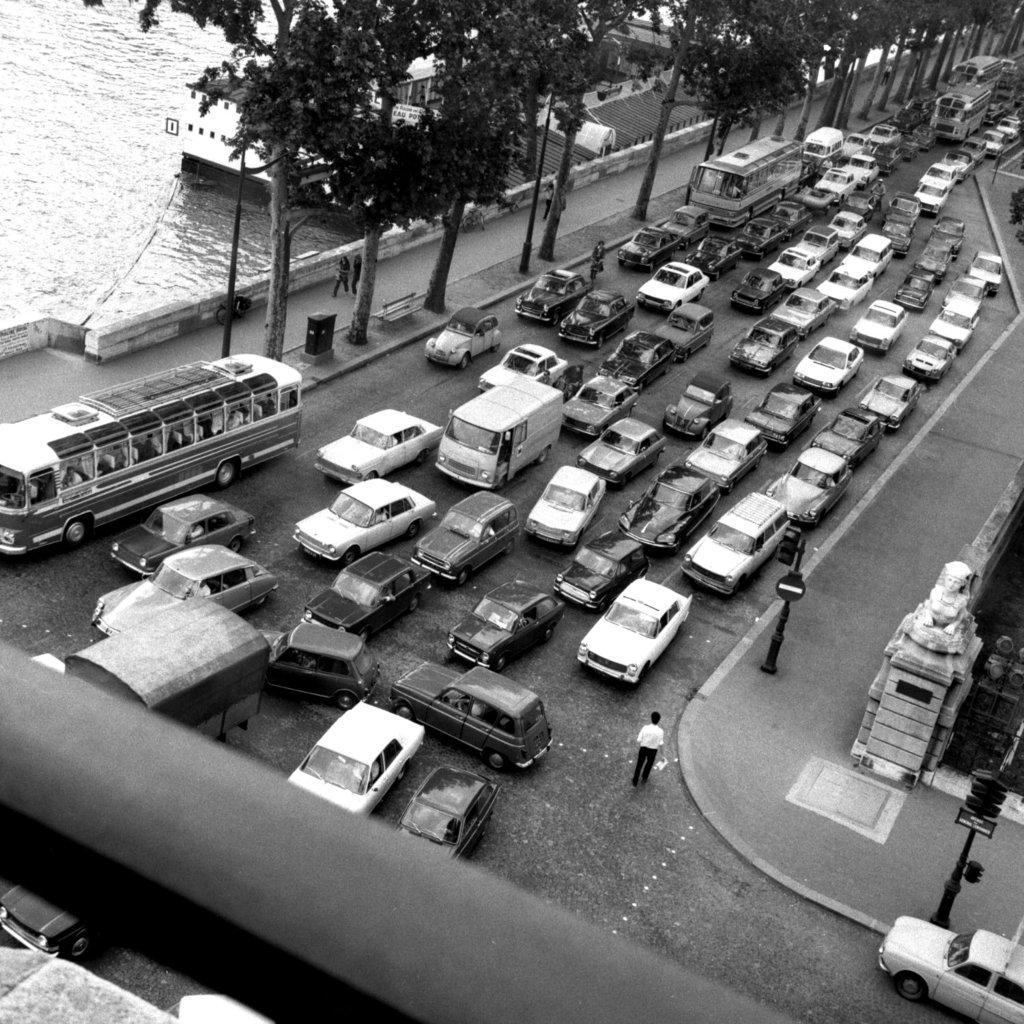In one or two sentences, can you explain what this image depicts? Here in this picture we can see number of cars, trucks and buses present on the road over there and we can also see people standing and walking on the road over there and we can see traffic signal lights present on poles and we can see light post, trees present over there and beside that we can see water present all over there. 